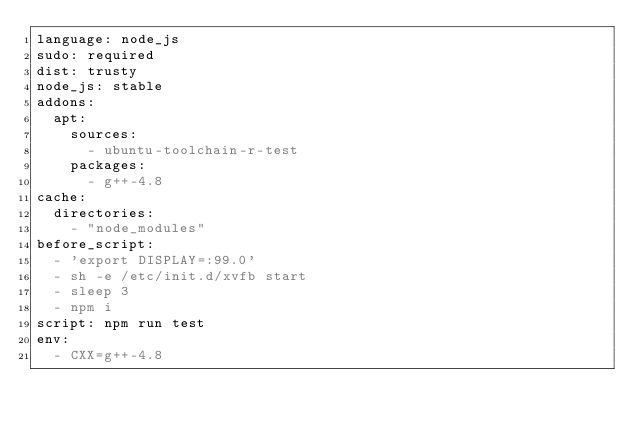<code> <loc_0><loc_0><loc_500><loc_500><_YAML_>language: node_js
sudo: required
dist: trusty
node_js: stable
addons:
  apt:
    sources:
      - ubuntu-toolchain-r-test
    packages:
      - g++-4.8
cache:
  directories:
    - "node_modules"
before_script:
  - 'export DISPLAY=:99.0'
  - sh -e /etc/init.d/xvfb start
  - sleep 3
  - npm i
script: npm run test
env:
  - CXX=g++-4.8
</code> 